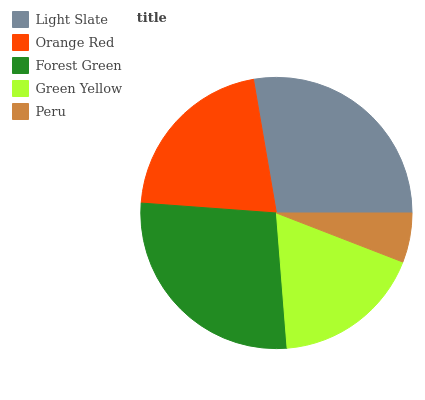Is Peru the minimum?
Answer yes or no. Yes. Is Light Slate the maximum?
Answer yes or no. Yes. Is Orange Red the minimum?
Answer yes or no. No. Is Orange Red the maximum?
Answer yes or no. No. Is Light Slate greater than Orange Red?
Answer yes or no. Yes. Is Orange Red less than Light Slate?
Answer yes or no. Yes. Is Orange Red greater than Light Slate?
Answer yes or no. No. Is Light Slate less than Orange Red?
Answer yes or no. No. Is Orange Red the high median?
Answer yes or no. Yes. Is Orange Red the low median?
Answer yes or no. Yes. Is Green Yellow the high median?
Answer yes or no. No. Is Forest Green the low median?
Answer yes or no. No. 